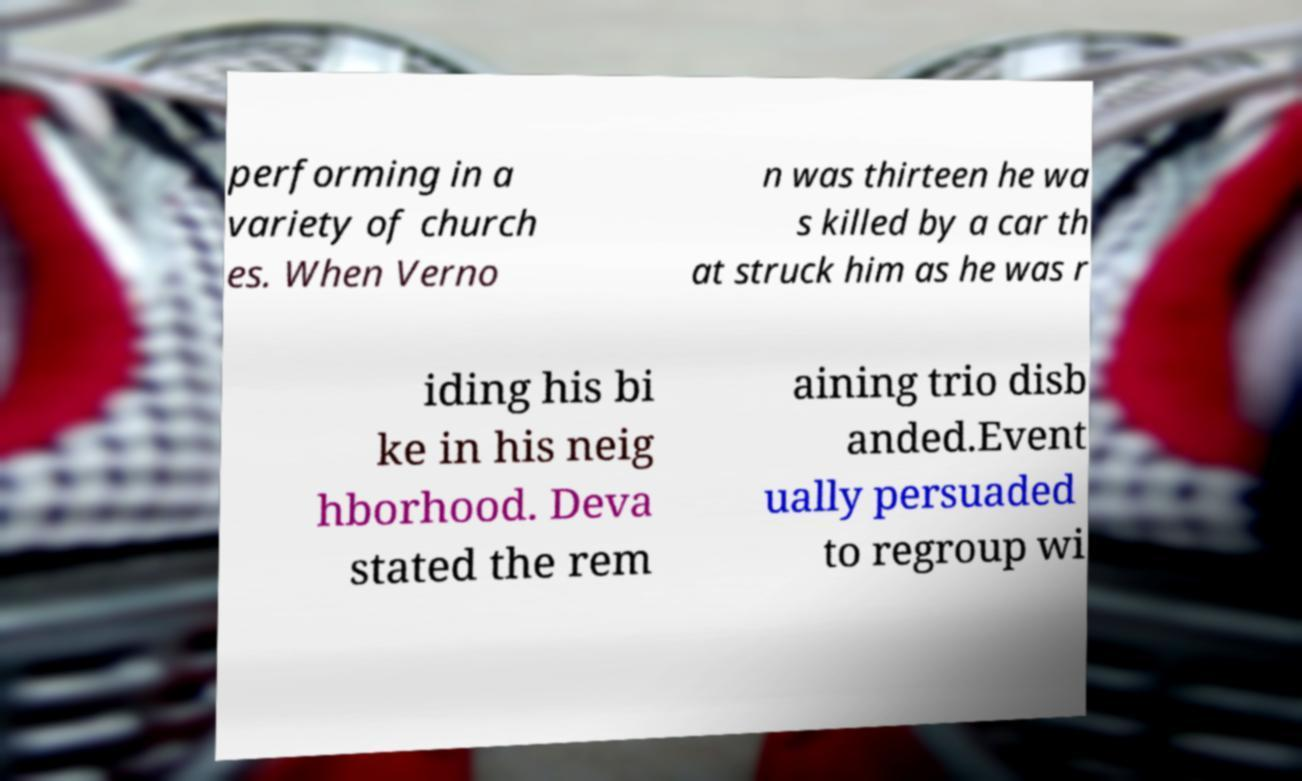For documentation purposes, I need the text within this image transcribed. Could you provide that? performing in a variety of church es. When Verno n was thirteen he wa s killed by a car th at struck him as he was r iding his bi ke in his neig hborhood. Deva stated the rem aining trio disb anded.Event ually persuaded to regroup wi 